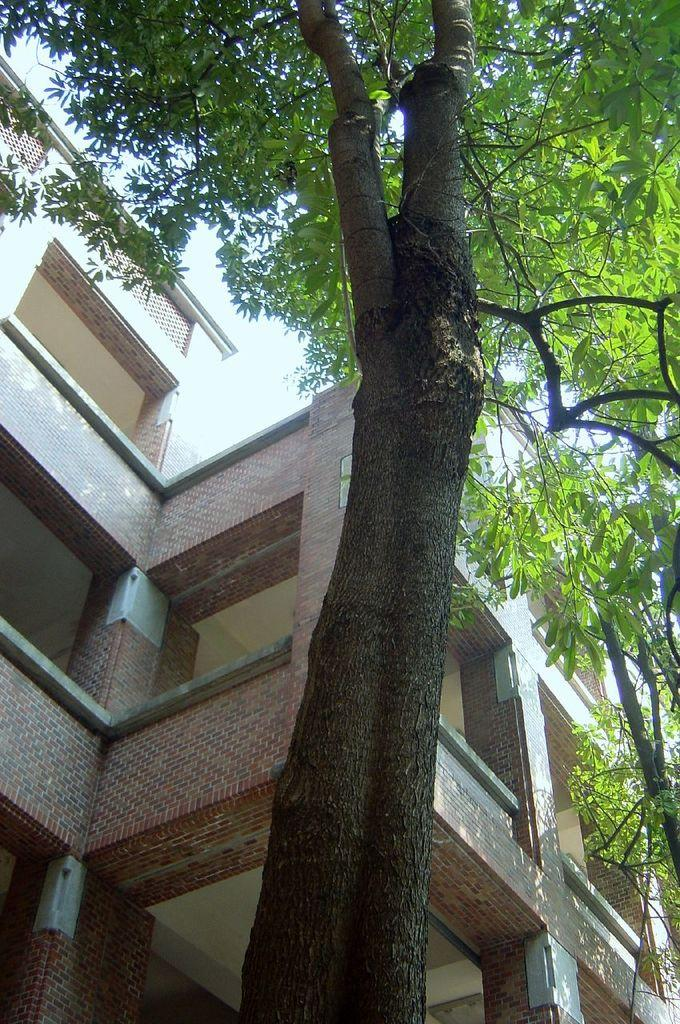What type of vegetation is in the foreground of the image? There are trees in the foreground of the image. What type of structure can be seen in the background of the image? There is a building in the background of the image. What part of the natural environment is visible in the background of the image? The sky is visible in the background of the image. How many geese are flying in the sky in the image? There are no geese visible in the image; it only features trees in the foreground, a building in the background, and the sky. What type of bait is being used to catch fish in the image? There is no fishing or bait present in the image. 